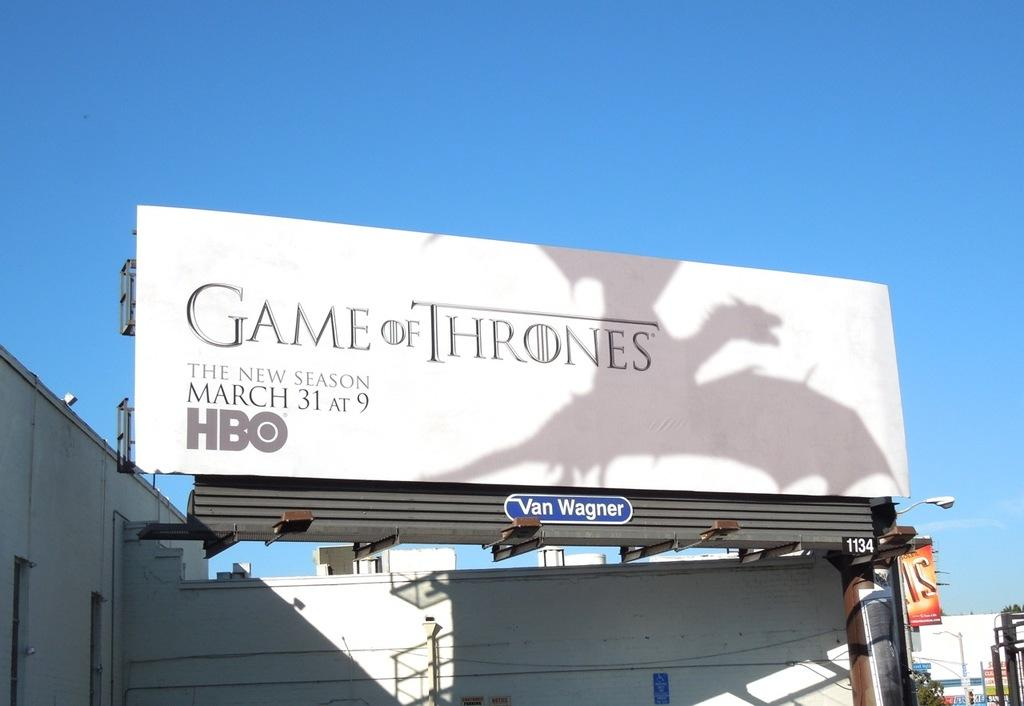<image>
Relay a brief, clear account of the picture shown. a billboard that says 'game of thrones' on it 